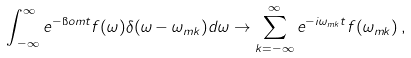<formula> <loc_0><loc_0><loc_500><loc_500>\int _ { \, - \infty } ^ { \infty } e ^ { - \i o m t } f ( \omega ) \delta ( \omega - \omega _ { m k } ) d \omega \to \sum _ { k = - \infty } ^ { \infty } e ^ { - i \omega _ { m k } t } f ( \omega _ { m k } ) \, ,</formula> 